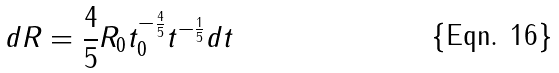Convert formula to latex. <formula><loc_0><loc_0><loc_500><loc_500>d R = \frac { 4 } { 5 } R _ { 0 } t _ { 0 } ^ { - \frac { 4 } { 5 } } t ^ { - \frac { 1 } { 5 } } d t</formula> 